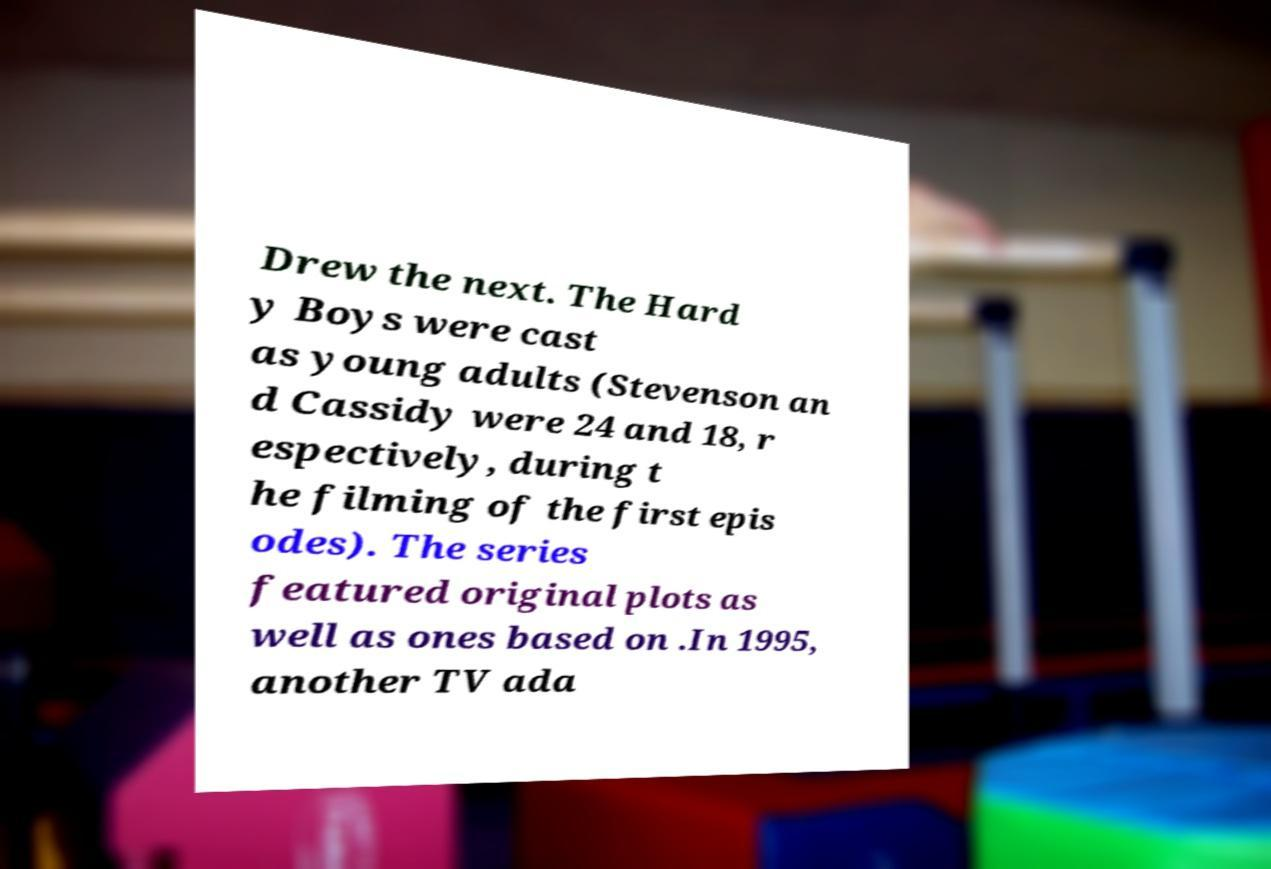Could you assist in decoding the text presented in this image and type it out clearly? Drew the next. The Hard y Boys were cast as young adults (Stevenson an d Cassidy were 24 and 18, r espectively, during t he filming of the first epis odes). The series featured original plots as well as ones based on .In 1995, another TV ada 